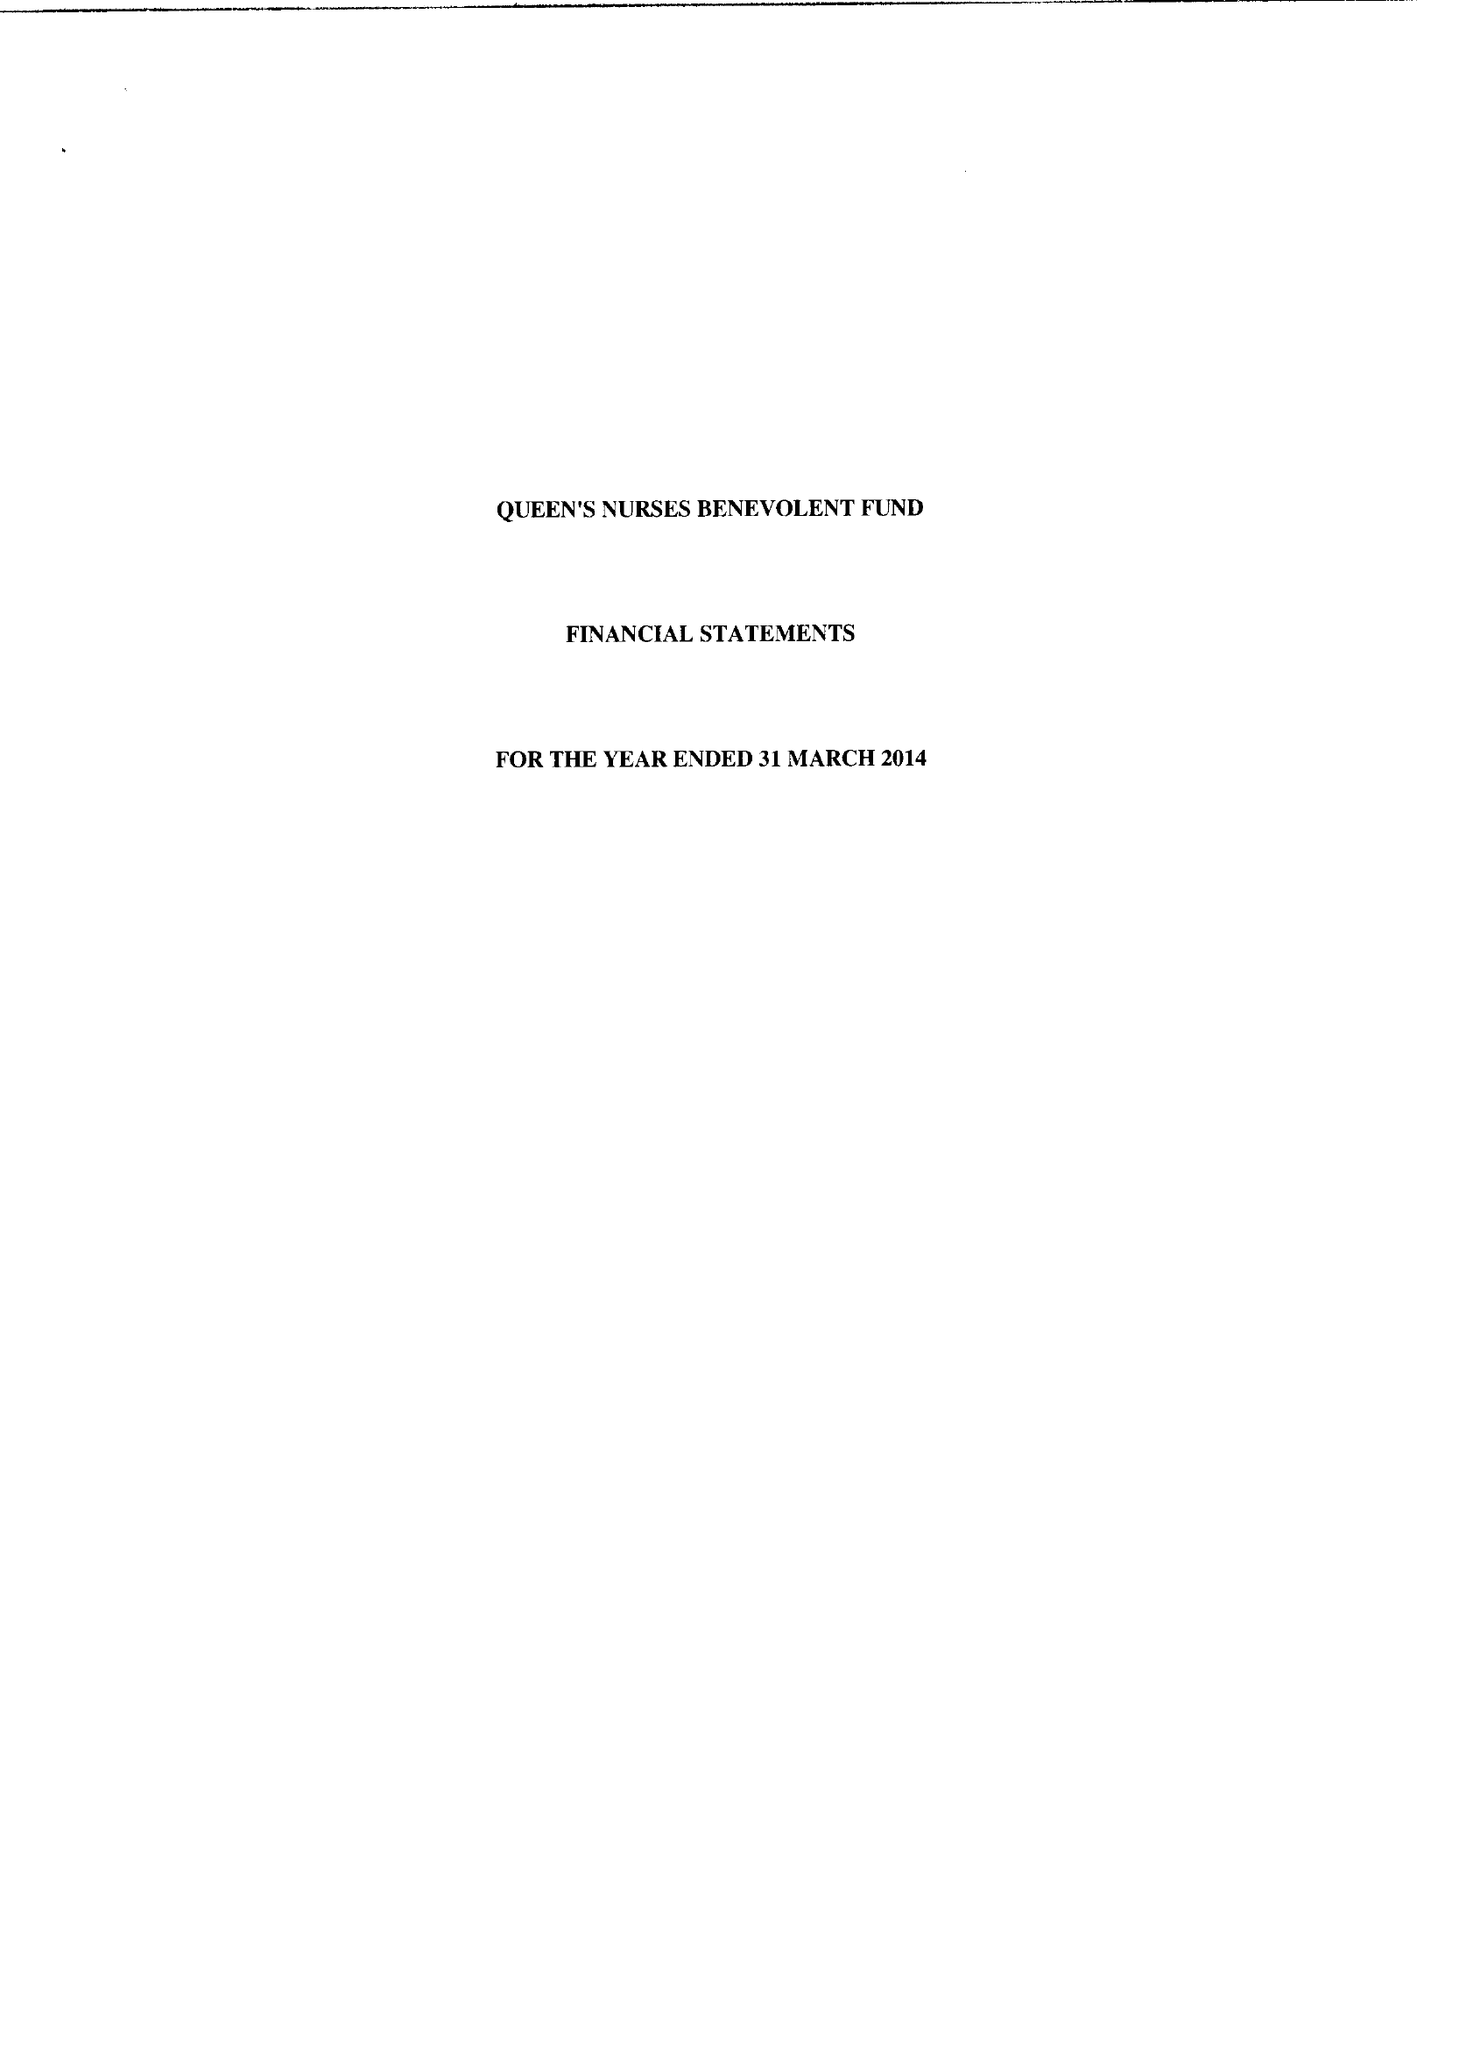What is the value for the spending_annually_in_british_pounds?
Answer the question using a single word or phrase. 106481.00 